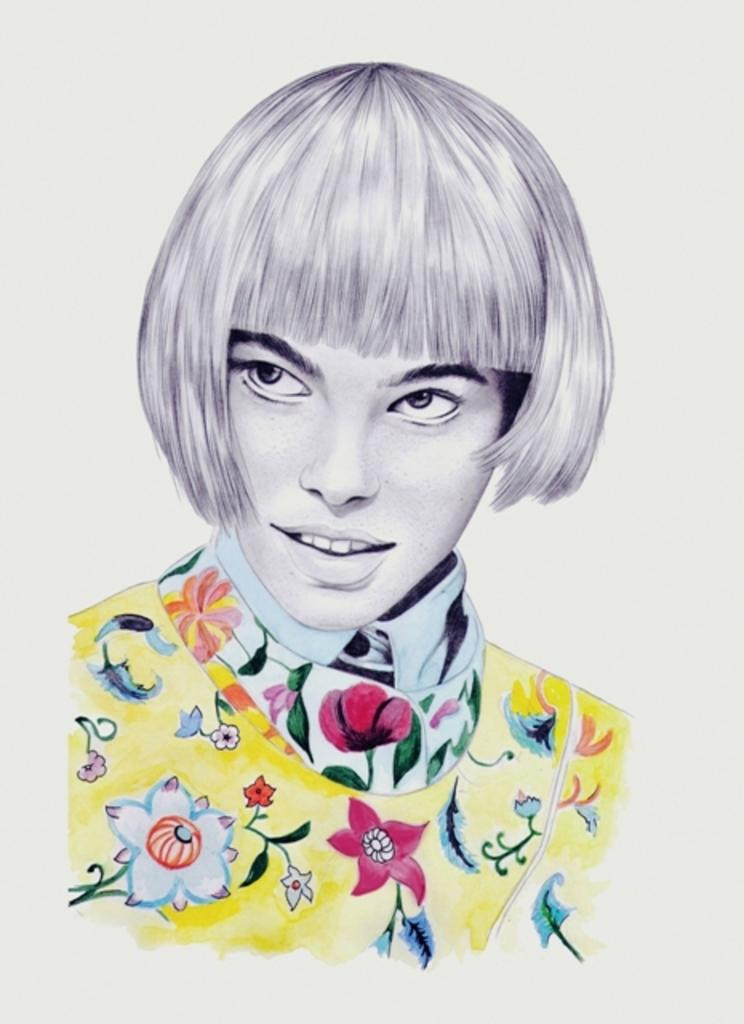What type of content is present in the image? The image contains art. Can you describe any subjects or figures in the art? There is a woman in the image. What type of oven is being used to create the art in the image? There is no oven present in the image, as it contains art and a woman. 